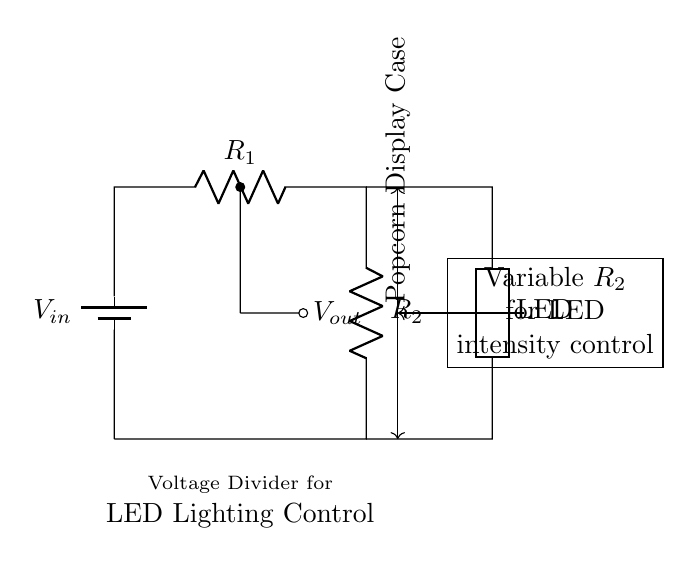What is the input voltage of this circuit? The input voltage, denoted as \( V_{in} \), is represented at the top of the circuit next to the battery symbol. It indicates the source voltage that powers the entire circuit.
Answer: \( V_{in} \) What is the function of the variable resistor \( R_2 \)? The variable resistor \( R_2 \) is used to control the intensity of the LED lighting. By adjusting \( R_2 \), the output voltage \( V_{out} \) changes, which in turn modifies the brightness of the LED.
Answer: LED intensity control Where does the output voltage \( V_{out} \) appear in the circuit? The output voltage \( V_{out} \) is taken from the junction between resistors \( R_1 \) and \( R_2 \). It is marked on the diagram and is the voltage used to light the LED.
Answer: Between \( R_1 \) and \( R_2 \) What is the relationship between \( R_1 \) and \( R_2 \) in this voltage divider? The output voltage \( V_{out} \) is determined by the resistances of \( R_1 \) and \( R_2 \). According to the voltage divider rule, \( V_{out} = V_{in} \times \frac{R_2}{R_1 + R_2} \), showcasing their direct influence on the output voltage.
Answer: Voltage divider rule How does increasing \( R_2 \) affect the LED brightness? Increasing \( R_2 \) raises the output voltage \( V_{out} \), leading to an increase in current through the LED, which causes it to glow brighter. This is a direct consequence of the voltage divider effect.
Answer: Increases brightness What type of circuit is this? This circuit is classified as a voltage divider, which is specifically used to reduce voltage and control lighting intensity in this application. It divides the input voltage between two resistors.
Answer: Voltage divider What happens if \( R_2 \) is set to zero ohms? If \( R_2 \) is zero ohms, it effectively creates a short circuit across it, causing the output voltage \( V_{out} \) to drop to zero. This would turn off the LED, as there would be no voltage available to power it.
Answer: Output voltage to zero 